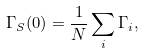Convert formula to latex. <formula><loc_0><loc_0><loc_500><loc_500>\Gamma _ { S } ( 0 ) = \frac { 1 } { N } \sum _ { i } \Gamma _ { i } ,</formula> 